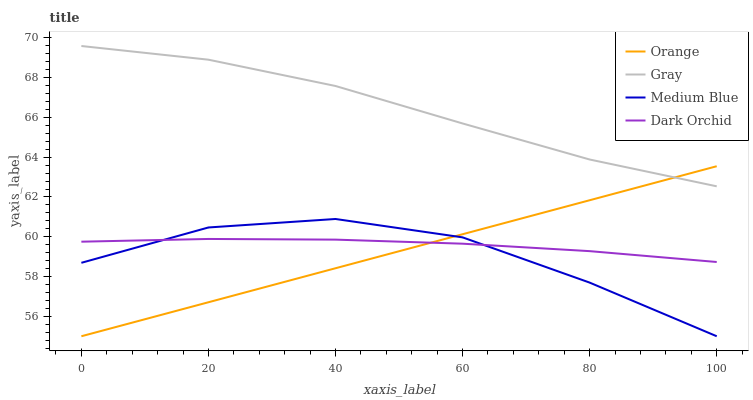Does Medium Blue have the minimum area under the curve?
Answer yes or no. Yes. Does Gray have the maximum area under the curve?
Answer yes or no. Yes. Does Gray have the minimum area under the curve?
Answer yes or no. No. Does Medium Blue have the maximum area under the curve?
Answer yes or no. No. Is Orange the smoothest?
Answer yes or no. Yes. Is Medium Blue the roughest?
Answer yes or no. Yes. Is Gray the smoothest?
Answer yes or no. No. Is Gray the roughest?
Answer yes or no. No. Does Orange have the lowest value?
Answer yes or no. Yes. Does Gray have the lowest value?
Answer yes or no. No. Does Gray have the highest value?
Answer yes or no. Yes. Does Medium Blue have the highest value?
Answer yes or no. No. Is Medium Blue less than Gray?
Answer yes or no. Yes. Is Gray greater than Medium Blue?
Answer yes or no. Yes. Does Orange intersect Dark Orchid?
Answer yes or no. Yes. Is Orange less than Dark Orchid?
Answer yes or no. No. Is Orange greater than Dark Orchid?
Answer yes or no. No. Does Medium Blue intersect Gray?
Answer yes or no. No. 